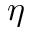Convert formula to latex. <formula><loc_0><loc_0><loc_500><loc_500>\eta</formula> 